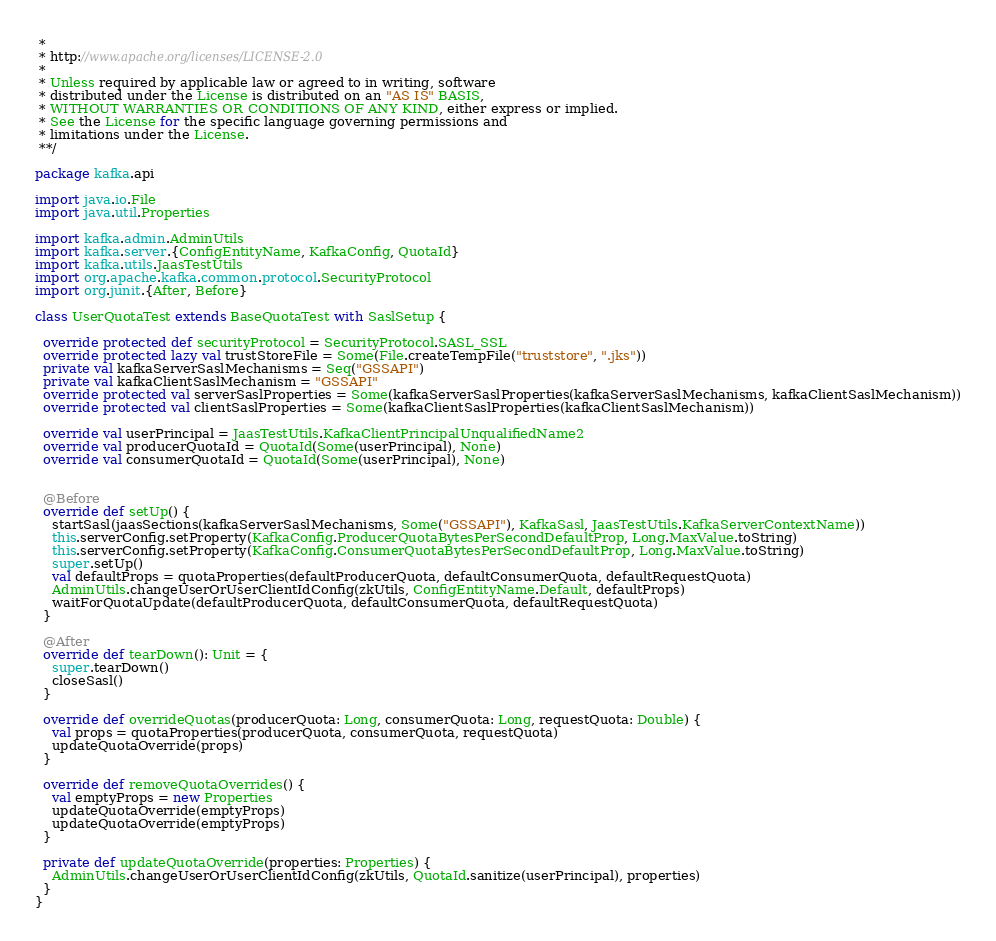Convert code to text. <code><loc_0><loc_0><loc_500><loc_500><_Scala_> *
 * http://www.apache.org/licenses/LICENSE-2.0
 *
 * Unless required by applicable law or agreed to in writing, software
 * distributed under the License is distributed on an "AS IS" BASIS,
 * WITHOUT WARRANTIES OR CONDITIONS OF ANY KIND, either express or implied.
 * See the License for the specific language governing permissions and
 * limitations under the License.
 **/

package kafka.api

import java.io.File
import java.util.Properties

import kafka.admin.AdminUtils
import kafka.server.{ConfigEntityName, KafkaConfig, QuotaId}
import kafka.utils.JaasTestUtils
import org.apache.kafka.common.protocol.SecurityProtocol
import org.junit.{After, Before}

class UserQuotaTest extends BaseQuotaTest with SaslSetup {

  override protected def securityProtocol = SecurityProtocol.SASL_SSL
  override protected lazy val trustStoreFile = Some(File.createTempFile("truststore", ".jks"))
  private val kafkaServerSaslMechanisms = Seq("GSSAPI")
  private val kafkaClientSaslMechanism = "GSSAPI"
  override protected val serverSaslProperties = Some(kafkaServerSaslProperties(kafkaServerSaslMechanisms, kafkaClientSaslMechanism))
  override protected val clientSaslProperties = Some(kafkaClientSaslProperties(kafkaClientSaslMechanism))

  override val userPrincipal = JaasTestUtils.KafkaClientPrincipalUnqualifiedName2
  override val producerQuotaId = QuotaId(Some(userPrincipal), None)
  override val consumerQuotaId = QuotaId(Some(userPrincipal), None)


  @Before
  override def setUp() {
    startSasl(jaasSections(kafkaServerSaslMechanisms, Some("GSSAPI"), KafkaSasl, JaasTestUtils.KafkaServerContextName))
    this.serverConfig.setProperty(KafkaConfig.ProducerQuotaBytesPerSecondDefaultProp, Long.MaxValue.toString)
    this.serverConfig.setProperty(KafkaConfig.ConsumerQuotaBytesPerSecondDefaultProp, Long.MaxValue.toString)
    super.setUp()
    val defaultProps = quotaProperties(defaultProducerQuota, defaultConsumerQuota, defaultRequestQuota)
    AdminUtils.changeUserOrUserClientIdConfig(zkUtils, ConfigEntityName.Default, defaultProps)
    waitForQuotaUpdate(defaultProducerQuota, defaultConsumerQuota, defaultRequestQuota)
  }

  @After
  override def tearDown(): Unit = {
    super.tearDown()
    closeSasl()
  }

  override def overrideQuotas(producerQuota: Long, consumerQuota: Long, requestQuota: Double) {
    val props = quotaProperties(producerQuota, consumerQuota, requestQuota)
    updateQuotaOverride(props)
  }

  override def removeQuotaOverrides() {
    val emptyProps = new Properties
    updateQuotaOverride(emptyProps)
    updateQuotaOverride(emptyProps)
  }

  private def updateQuotaOverride(properties: Properties) {
    AdminUtils.changeUserOrUserClientIdConfig(zkUtils, QuotaId.sanitize(userPrincipal), properties)
  }
}
</code> 